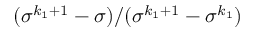Convert formula to latex. <formula><loc_0><loc_0><loc_500><loc_500>( \sigma ^ { k _ { 1 } + 1 } - \sigma ) / ( \sigma ^ { k _ { 1 } + 1 } - \sigma ^ { k _ { 1 } } )</formula> 